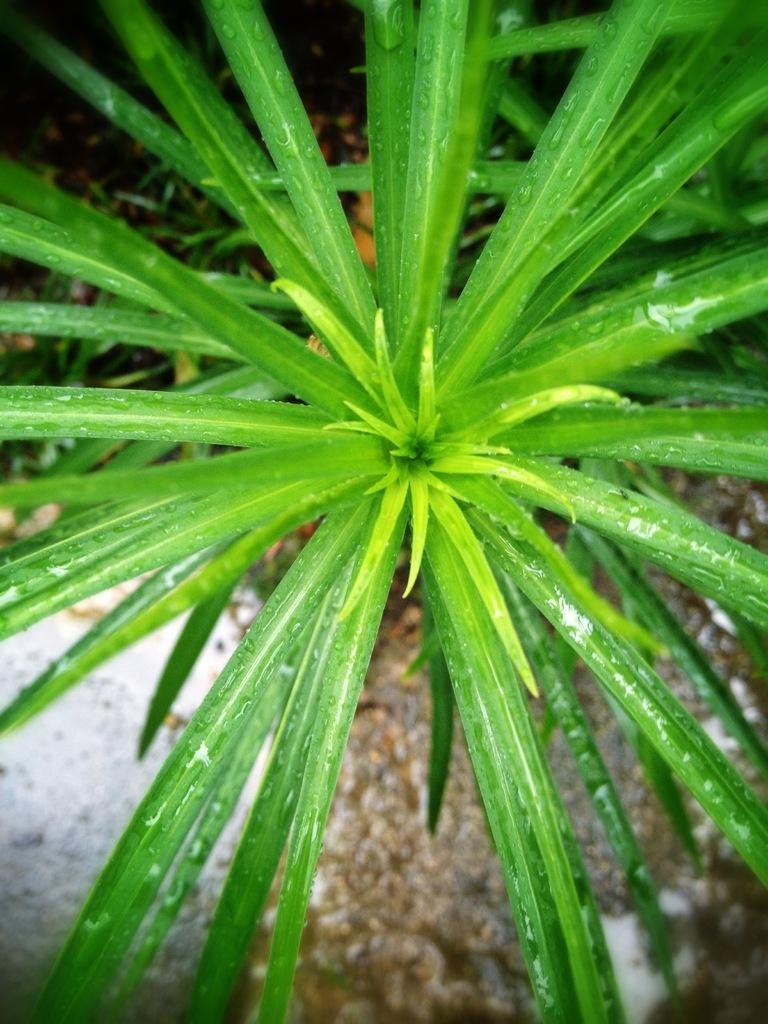What type of living organisms can be seen in the image? Plants can be seen in the image. What else is visible on the ground in the image? There are objects visible on the ground in the image. How many dimes can be seen on the ground in the image? There is no mention of dimes in the image, so it cannot be determined how many dimes are present. What type of activity is taking place during the recess in the image? There is no mention of a recess or any activity in the image. 